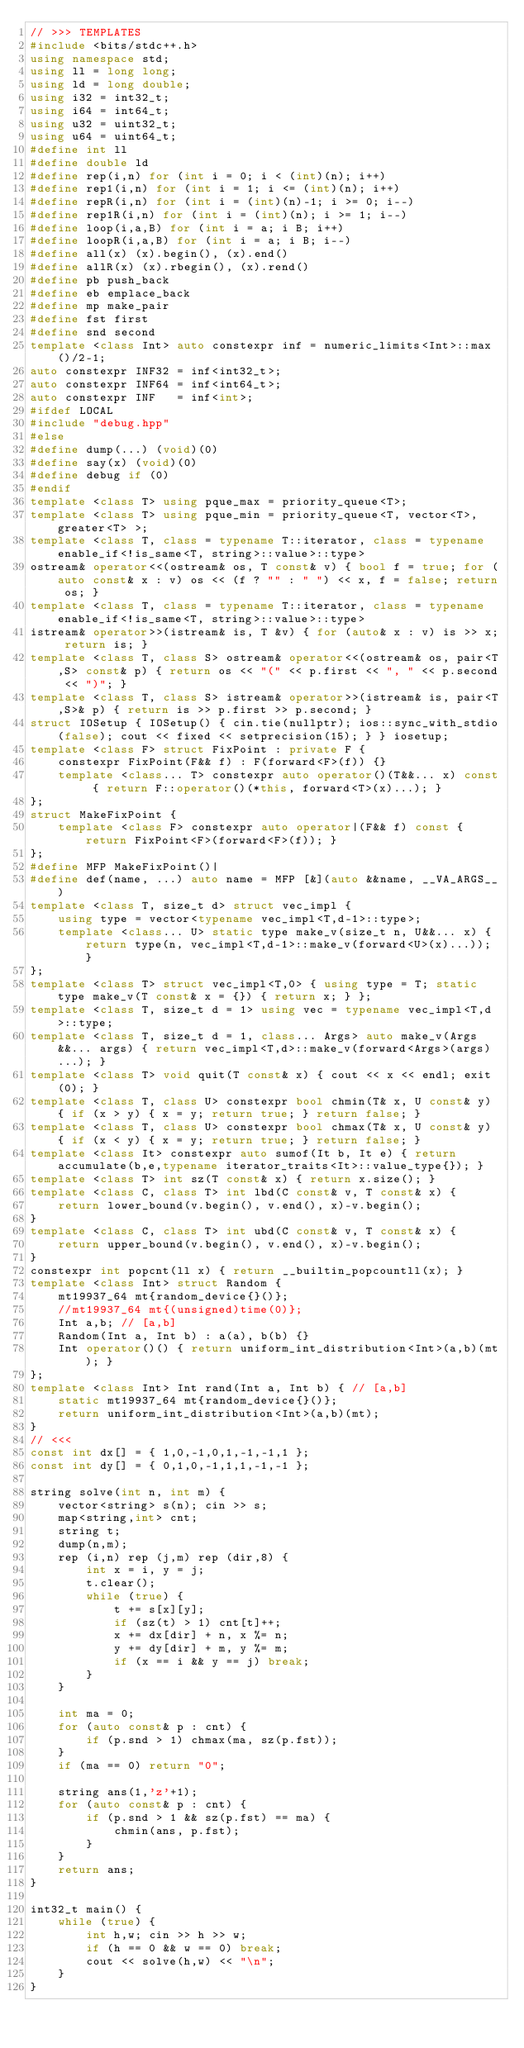Convert code to text. <code><loc_0><loc_0><loc_500><loc_500><_C++_>// >>> TEMPLATES
#include <bits/stdc++.h>
using namespace std;
using ll = long long;
using ld = long double;
using i32 = int32_t;
using i64 = int64_t;
using u32 = uint32_t;
using u64 = uint64_t;
#define int ll
#define double ld
#define rep(i,n) for (int i = 0; i < (int)(n); i++)
#define rep1(i,n) for (int i = 1; i <= (int)(n); i++)
#define repR(i,n) for (int i = (int)(n)-1; i >= 0; i--)
#define rep1R(i,n) for (int i = (int)(n); i >= 1; i--)
#define loop(i,a,B) for (int i = a; i B; i++)
#define loopR(i,a,B) for (int i = a; i B; i--)
#define all(x) (x).begin(), (x).end()
#define allR(x) (x).rbegin(), (x).rend()
#define pb push_back
#define eb emplace_back
#define mp make_pair
#define fst first
#define snd second
template <class Int> auto constexpr inf = numeric_limits<Int>::max()/2-1;
auto constexpr INF32 = inf<int32_t>;
auto constexpr INF64 = inf<int64_t>;
auto constexpr INF   = inf<int>;
#ifdef LOCAL
#include "debug.hpp"
#else
#define dump(...) (void)(0)
#define say(x) (void)(0)
#define debug if (0)
#endif
template <class T> using pque_max = priority_queue<T>;
template <class T> using pque_min = priority_queue<T, vector<T>, greater<T> >;
template <class T, class = typename T::iterator, class = typename enable_if<!is_same<T, string>::value>::type>
ostream& operator<<(ostream& os, T const& v) { bool f = true; for (auto const& x : v) os << (f ? "" : " ") << x, f = false; return os; }
template <class T, class = typename T::iterator, class = typename enable_if<!is_same<T, string>::value>::type>
istream& operator>>(istream& is, T &v) { for (auto& x : v) is >> x; return is; }
template <class T, class S> ostream& operator<<(ostream& os, pair<T,S> const& p) { return os << "(" << p.first << ", " << p.second << ")"; }
template <class T, class S> istream& operator>>(istream& is, pair<T,S>& p) { return is >> p.first >> p.second; }
struct IOSetup { IOSetup() { cin.tie(nullptr); ios::sync_with_stdio(false); cout << fixed << setprecision(15); } } iosetup;
template <class F> struct FixPoint : private F {
    constexpr FixPoint(F&& f) : F(forward<F>(f)) {}
    template <class... T> constexpr auto operator()(T&&... x) const { return F::operator()(*this, forward<T>(x)...); }
};
struct MakeFixPoint {
    template <class F> constexpr auto operator|(F&& f) const { return FixPoint<F>(forward<F>(f)); }
};
#define MFP MakeFixPoint()|
#define def(name, ...) auto name = MFP [&](auto &&name, __VA_ARGS__)
template <class T, size_t d> struct vec_impl {
    using type = vector<typename vec_impl<T,d-1>::type>;
    template <class... U> static type make_v(size_t n, U&&... x) { return type(n, vec_impl<T,d-1>::make_v(forward<U>(x)...)); }
};
template <class T> struct vec_impl<T,0> { using type = T; static type make_v(T const& x = {}) { return x; } };
template <class T, size_t d = 1> using vec = typename vec_impl<T,d>::type;
template <class T, size_t d = 1, class... Args> auto make_v(Args&&... args) { return vec_impl<T,d>::make_v(forward<Args>(args)...); }
template <class T> void quit(T const& x) { cout << x << endl; exit(0); }
template <class T, class U> constexpr bool chmin(T& x, U const& y) { if (x > y) { x = y; return true; } return false; }
template <class T, class U> constexpr bool chmax(T& x, U const& y) { if (x < y) { x = y; return true; } return false; }
template <class It> constexpr auto sumof(It b, It e) { return accumulate(b,e,typename iterator_traits<It>::value_type{}); }
template <class T> int sz(T const& x) { return x.size(); }
template <class C, class T> int lbd(C const& v, T const& x) {
    return lower_bound(v.begin(), v.end(), x)-v.begin();
}
template <class C, class T> int ubd(C const& v, T const& x) {
    return upper_bound(v.begin(), v.end(), x)-v.begin();
}
constexpr int popcnt(ll x) { return __builtin_popcountll(x); }
template <class Int> struct Random {
    mt19937_64 mt{random_device{}()};
    //mt19937_64 mt{(unsigned)time(0)};
    Int a,b; // [a,b]
    Random(Int a, Int b) : a(a), b(b) {}
    Int operator()() { return uniform_int_distribution<Int>(a,b)(mt); }
};
template <class Int> Int rand(Int a, Int b) { // [a,b]
    static mt19937_64 mt{random_device{}()};
    return uniform_int_distribution<Int>(a,b)(mt);
}
// <<<
const int dx[] = { 1,0,-1,0,1,-1,-1,1 };
const int dy[] = { 0,1,0,-1,1,1,-1,-1 };

string solve(int n, int m) {
    vector<string> s(n); cin >> s;
    map<string,int> cnt;
    string t;
    dump(n,m);
    rep (i,n) rep (j,m) rep (dir,8) {
        int x = i, y = j;
        t.clear();
        while (true) {
            t += s[x][y];
            if (sz(t) > 1) cnt[t]++;
            x += dx[dir] + n, x %= n;
            y += dy[dir] + m, y %= m;
            if (x == i && y == j) break;
        }
    }

    int ma = 0;
    for (auto const& p : cnt) {
        if (p.snd > 1) chmax(ma, sz(p.fst));
    }
    if (ma == 0) return "0";

    string ans(1,'z'+1);
    for (auto const& p : cnt) {
        if (p.snd > 1 && sz(p.fst) == ma) {
            chmin(ans, p.fst);
        }
    }
    return ans;
}

int32_t main() {
    while (true) {
        int h,w; cin >> h >> w;
        if (h == 0 && w == 0) break;
        cout << solve(h,w) << "\n";
    }
}

</code> 